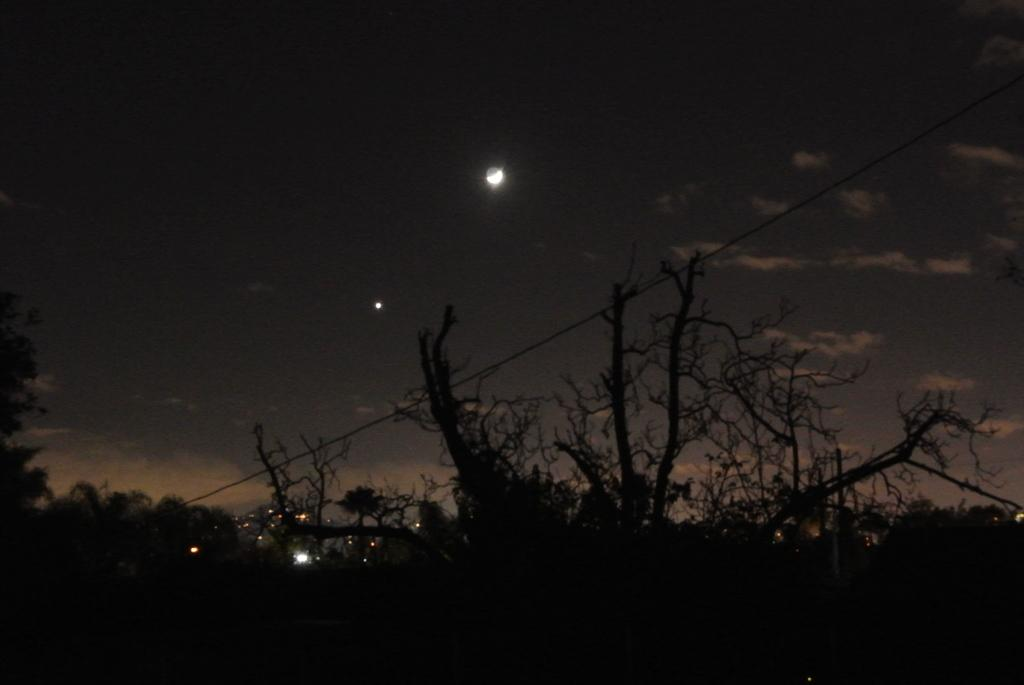What is located at the bottom of the image? There are trees and lights at the bottom of the image. What else can be seen at the bottom of the image? There is also a wire at the bottom of the image. What is visible in the background of the image? The sky is visible in the background of the image. What celestial body can be seen in the sky? The moon is visible in the sky. How many fifths are present in the image? There is no reference to a "fifth" in the image, so it is not possible to determine how many there are. Can you describe the type of tree that is visible in the image? The provided facts do not specify the type of tree; only that there are trees present. 